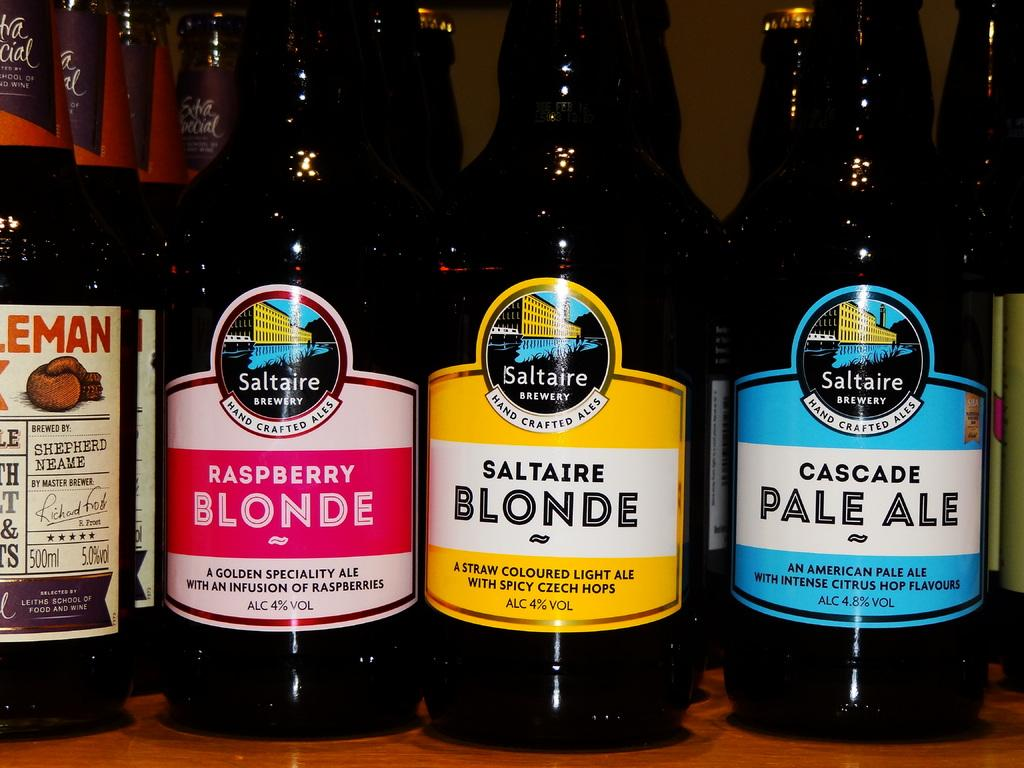<image>
Describe the image concisely. bottles of raspberryand saltaire blonde with cascade pale ale 